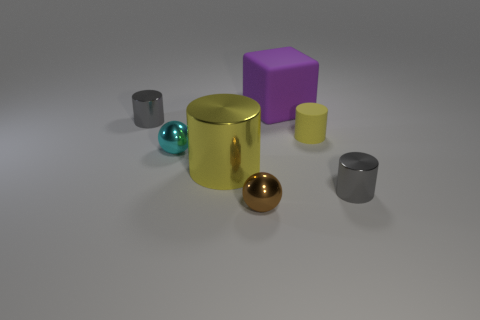There is a tiny gray cylinder that is on the left side of the small gray shiny object on the right side of the cyan ball; what is it made of?
Ensure brevity in your answer.  Metal. There is a large thing that is the same color as the small rubber cylinder; what material is it?
Your answer should be very brief. Metal. Do the rubber cube and the yellow metal thing have the same size?
Keep it short and to the point. Yes. There is a gray metal cylinder that is to the right of the large cube; are there any small yellow rubber things in front of it?
Offer a terse response. No. What size is the other rubber cylinder that is the same color as the big cylinder?
Provide a succinct answer. Small. The small gray metal thing on the right side of the small brown object has what shape?
Make the answer very short. Cylinder. There is a gray shiny object to the right of the gray object that is behind the big yellow cylinder; how many small gray cylinders are in front of it?
Give a very brief answer. 0. Do the brown ball and the gray shiny object that is in front of the small matte object have the same size?
Your response must be concise. Yes. What is the size of the gray metallic cylinder in front of the gray metallic cylinder behind the big yellow object?
Give a very brief answer. Small. What number of purple objects are the same material as the block?
Provide a succinct answer. 0. 